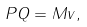<formula> <loc_0><loc_0><loc_500><loc_500>P Q = M v ,</formula> 